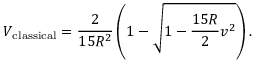<formula> <loc_0><loc_0><loc_500><loc_500>V _ { c l a s s i c a l } = \frac { 2 } { 1 5 R ^ { 2 } } \left ( 1 - \sqrt { 1 - \frac { 1 5 R } { 2 } v ^ { 2 } } \right ) .</formula> 